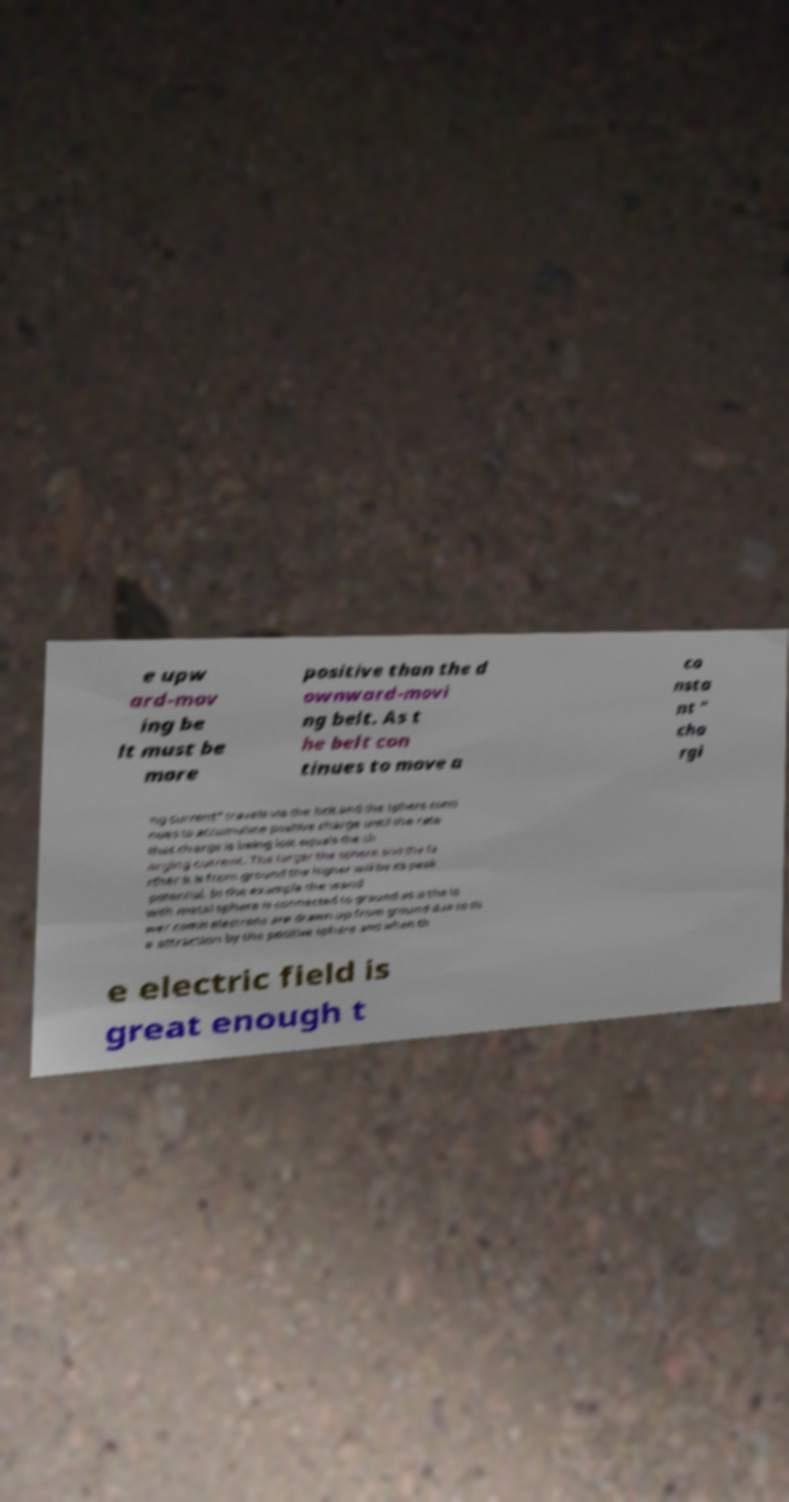Can you accurately transcribe the text from the provided image for me? e upw ard-mov ing be lt must be more positive than the d ownward-movi ng belt. As t he belt con tinues to move a co nsta nt " cha rgi ng current" travels via the belt and the sphere conti nues to accumulate positive charge until the rate that charge is being lost equals the ch arging current. The larger the sphere and the fa rther it is from ground the higher will be its peak potential. In the example the wand with metal sphere is connected to ground as is the lo wer comb electrons are drawn up from ground due to th e attraction by the positive sphere and when th e electric field is great enough t 